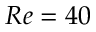<formula> <loc_0><loc_0><loc_500><loc_500>R e = 4 0</formula> 